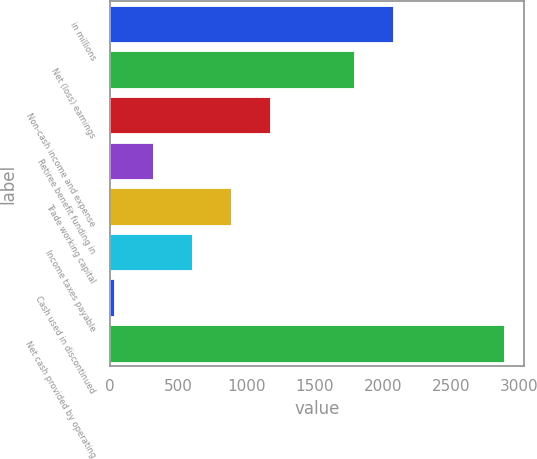Convert chart to OTSL. <chart><loc_0><loc_0><loc_500><loc_500><bar_chart><fcel>in millions<fcel>Net (loss) earnings<fcel>Non-cash income and expense<fcel>Retiree benefit funding in<fcel>Trade working capital<fcel>Income taxes payable<fcel>Cash used in discontinued<fcel>Net cash provided by operating<nl><fcel>2076.5<fcel>1790<fcel>1171<fcel>311.5<fcel>884.5<fcel>598<fcel>25<fcel>2890<nl></chart> 